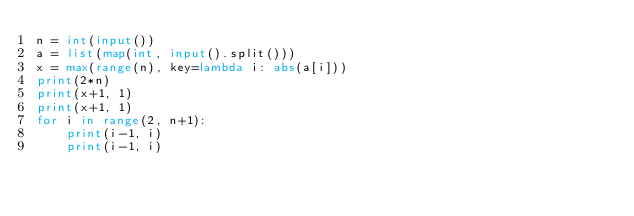Convert code to text. <code><loc_0><loc_0><loc_500><loc_500><_Python_>n = int(input())
a = list(map(int, input().split()))
x = max(range(n), key=lambda i: abs(a[i]))
print(2*n)
print(x+1, 1)
print(x+1, 1)
for i in range(2, n+1):
    print(i-1, i)
    print(i-1, i)</code> 